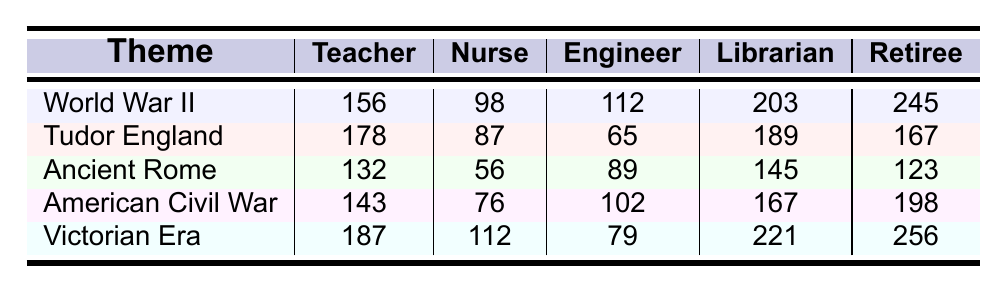What is the highest number of borrowings for a theme by Retirees? By examining the "Retiree" column in the table, I see that "Victorian Era" has the highest borrowings at 256.
Answer: 256 Which theme was borrowed the least by Nurses? Looking at the "Nurse" column, "Ancient Rome" has the lowest borrowings with a total of 56.
Answer: 56 What is the total number of borrowings for World War II across all occupations? To find the total for "World War II," I sum the values: 156 (Teacher) + 98 (Nurse) + 112 (Engineer) + 203 (Librarian) + 245 (Retiree) = 814.
Answer: 814 How does the borrowing of the Victorian Era compare to the American Civil War among Teachers? The Victorian Era has 187 borrowings from Teachers, while the American Civil War has 143. The Victorian Era is higher by 44 borrowings (187 - 143).
Answer: 44 Are most borrowings for Tudor England from Teachers? In the "Tudor England" row, Teachers borrowed 178, which is more than any other occupation: Nurse 87, Engineer 65, Librarian 189, Retiree 167. Since Librarians borrowed 189, the statement is false.
Answer: No What is the difference in borrowings between Librarians for Ancient Rome and World War II? Librarians borrowed 145 for Ancient Rome and 203 for World War II. The difference is 203 - 145 = 58.
Answer: 58 Which occupation borrowed the most historical fiction novels in total? Summing the total for all occupations: Teacher (156 + 178 + 132 + 143 + 187), Nurse (98 + 87 + 56 + 76 + 112), Engineer (112 + 65 + 89 + 102 + 79), Librarian (203 + 189 + 145 + 167 + 221), and Retiree (245 + 167 + 123 + 198 + 256). Librarians borrowed the most with a total of 1,125.
Answer: Librarian Is there any theme where Engineers borrowed less than Nurses? In the table, for all themes, Nurses borrowed (98, 87, 56, 76, 112) while Engineers borrowed (112, 65, 89, 102, 79). Engineers borrowed less than Nurses only in "Tudor England," where Nurses borrowed 87 and Engineers only 65.
Answer: Yes What is the average number of borrowings for the Victorian Era among all occupations? To calculate the average for the Victorian Era, sum the borrowings: 187 (Teacher) + 112 (Nurse) + 79 (Engineer) + 221 (Librarian) + 256 (Retiree) = 855. There are 5 occupations, so the average is 855 / 5 = 171.
Answer: 171 Which theme had the highest borrowings for Teachers? In the "Teacher" column, the highest borrowing is for the "Victorian Era," with 187 borrowings compared to World War II (156), Tudor England (178), Ancient Rome (132), and American Civil War (143).
Answer: Victorian Era 